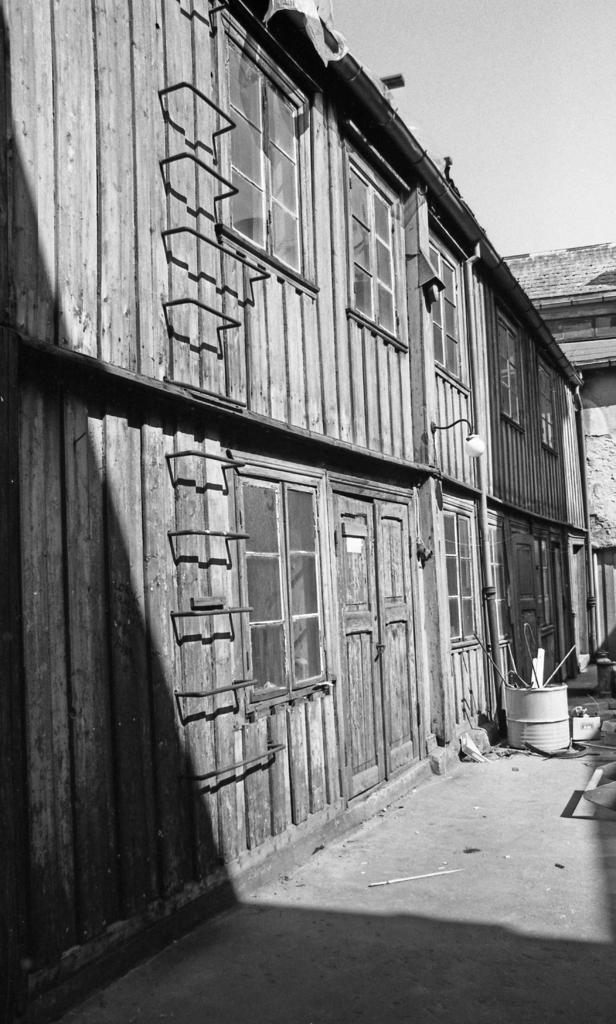Could you give a brief overview of what you see in this image? In this image, at the left side there is a house, there are some glass windows, there is a wooden door, there is a white color barrel kept on the ground, at the top there is a sky. 